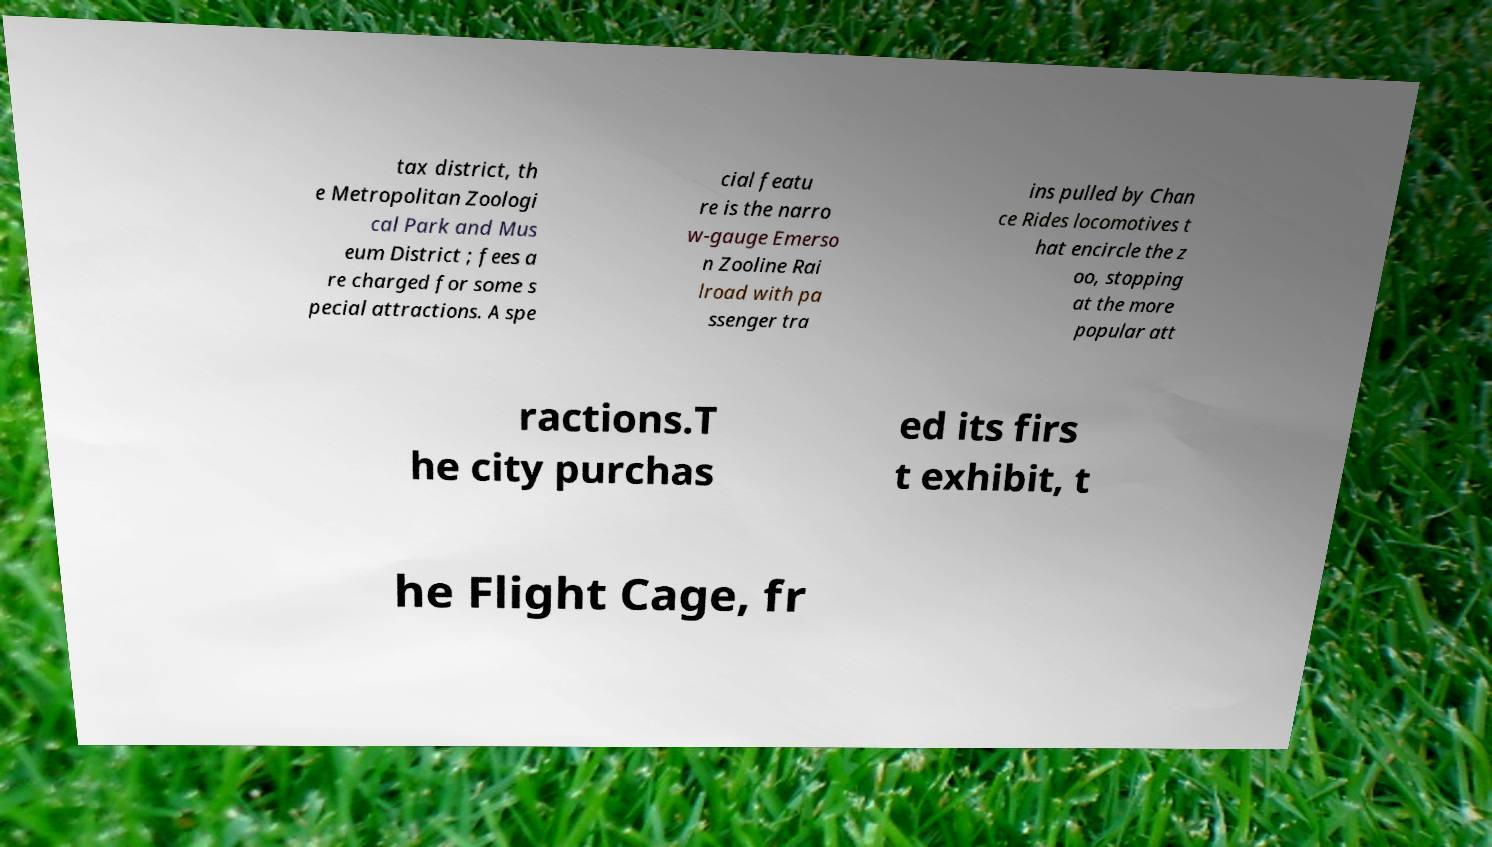What messages or text are displayed in this image? I need them in a readable, typed format. tax district, th e Metropolitan Zoologi cal Park and Mus eum District ; fees a re charged for some s pecial attractions. A spe cial featu re is the narro w-gauge Emerso n Zooline Rai lroad with pa ssenger tra ins pulled by Chan ce Rides locomotives t hat encircle the z oo, stopping at the more popular att ractions.T he city purchas ed its firs t exhibit, t he Flight Cage, fr 